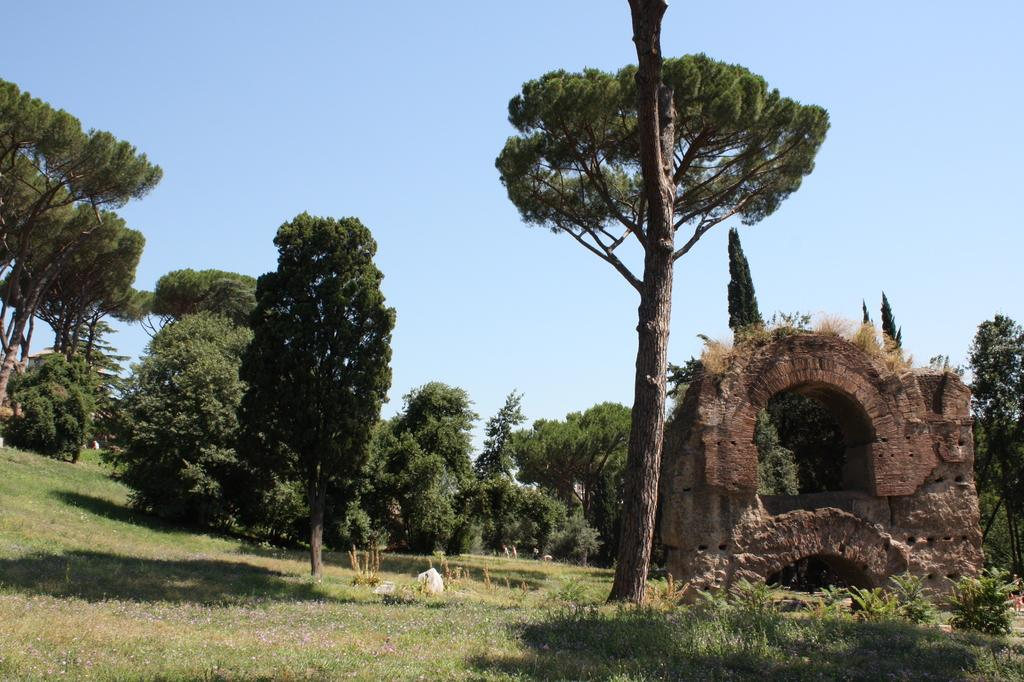What type of vegetation can be seen in the image? There are trees in the image. What type of structure is present in the image? There is a small fort in the image. What is visible at the top of the image? The sky is visible at the top of the image. What is visible at the bottom of the image? The ground is visible at the bottom of the image. Where is the library located in the image? There is no library present in the image. Is there a volcano erupting in the background of the image? There is no volcano present in the image. 